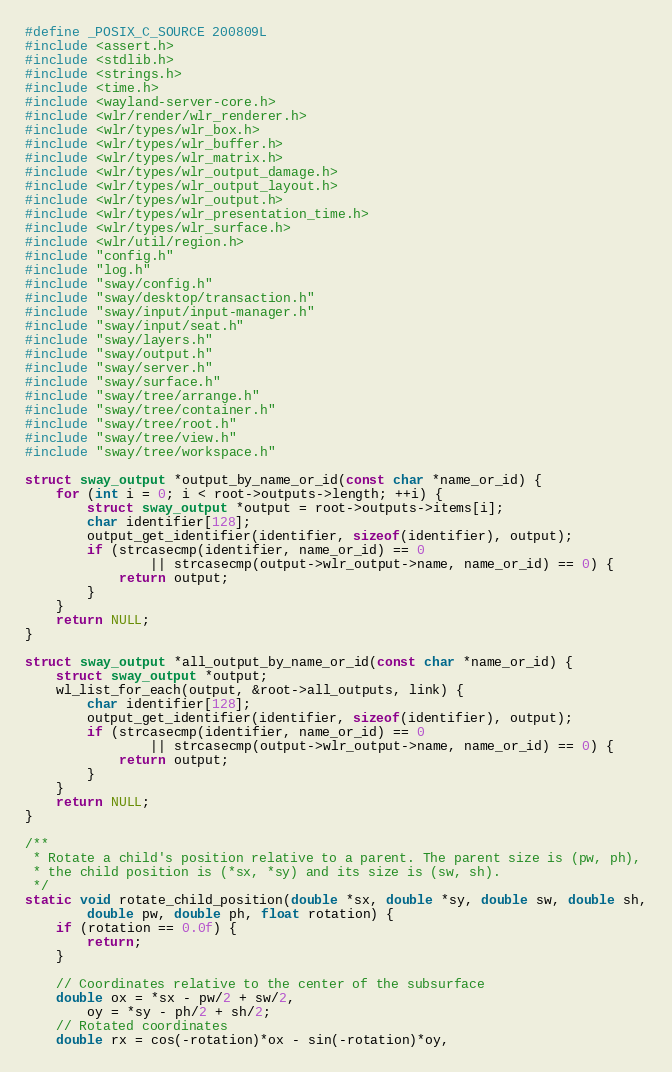Convert code to text. <code><loc_0><loc_0><loc_500><loc_500><_C_>#define _POSIX_C_SOURCE 200809L
#include <assert.h>
#include <stdlib.h>
#include <strings.h>
#include <time.h>
#include <wayland-server-core.h>
#include <wlr/render/wlr_renderer.h>
#include <wlr/types/wlr_box.h>
#include <wlr/types/wlr_buffer.h>
#include <wlr/types/wlr_matrix.h>
#include <wlr/types/wlr_output_damage.h>
#include <wlr/types/wlr_output_layout.h>
#include <wlr/types/wlr_output.h>
#include <wlr/types/wlr_presentation_time.h>
#include <wlr/types/wlr_surface.h>
#include <wlr/util/region.h>
#include "config.h"
#include "log.h"
#include "sway/config.h"
#include "sway/desktop/transaction.h"
#include "sway/input/input-manager.h"
#include "sway/input/seat.h"
#include "sway/layers.h"
#include "sway/output.h"
#include "sway/server.h"
#include "sway/surface.h"
#include "sway/tree/arrange.h"
#include "sway/tree/container.h"
#include "sway/tree/root.h"
#include "sway/tree/view.h"
#include "sway/tree/workspace.h"

struct sway_output *output_by_name_or_id(const char *name_or_id) {
	for (int i = 0; i < root->outputs->length; ++i) {
		struct sway_output *output = root->outputs->items[i];
		char identifier[128];
		output_get_identifier(identifier, sizeof(identifier), output);
		if (strcasecmp(identifier, name_or_id) == 0
				|| strcasecmp(output->wlr_output->name, name_or_id) == 0) {
			return output;
		}
	}
	return NULL;
}

struct sway_output *all_output_by_name_or_id(const char *name_or_id) {
	struct sway_output *output;
	wl_list_for_each(output, &root->all_outputs, link) {
		char identifier[128];
		output_get_identifier(identifier, sizeof(identifier), output);
		if (strcasecmp(identifier, name_or_id) == 0
				|| strcasecmp(output->wlr_output->name, name_or_id) == 0) {
			return output;
		}
	}
	return NULL;
}

/**
 * Rotate a child's position relative to a parent. The parent size is (pw, ph),
 * the child position is (*sx, *sy) and its size is (sw, sh).
 */
static void rotate_child_position(double *sx, double *sy, double sw, double sh,
		double pw, double ph, float rotation) {
	if (rotation == 0.0f) {
		return;
	}

	// Coordinates relative to the center of the subsurface
	double ox = *sx - pw/2 + sw/2,
		oy = *sy - ph/2 + sh/2;
	// Rotated coordinates
	double rx = cos(-rotation)*ox - sin(-rotation)*oy,</code> 